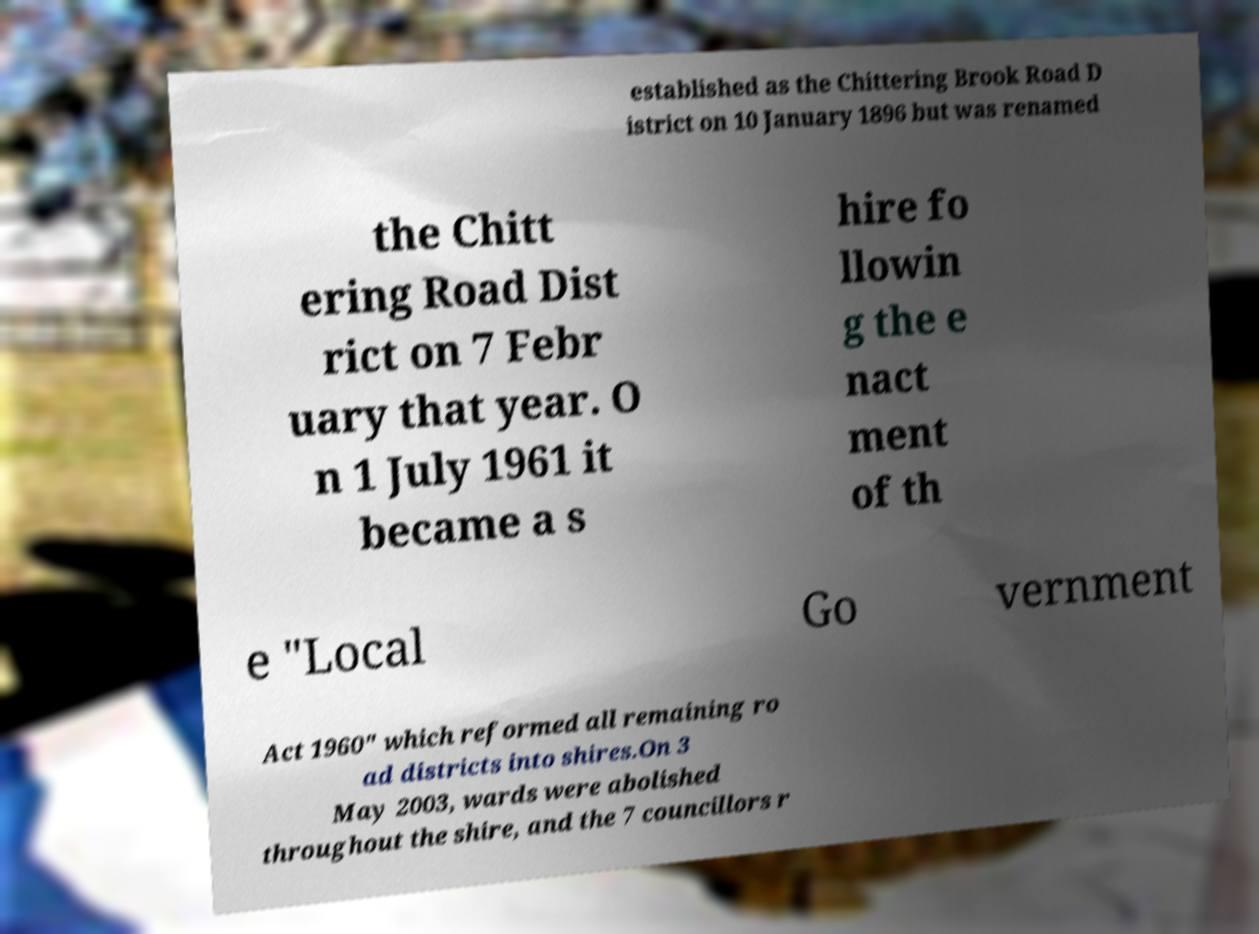Can you accurately transcribe the text from the provided image for me? established as the Chittering Brook Road D istrict on 10 January 1896 but was renamed the Chitt ering Road Dist rict on 7 Febr uary that year. O n 1 July 1961 it became a s hire fo llowin g the e nact ment of th e "Local Go vernment Act 1960" which reformed all remaining ro ad districts into shires.On 3 May 2003, wards were abolished throughout the shire, and the 7 councillors r 